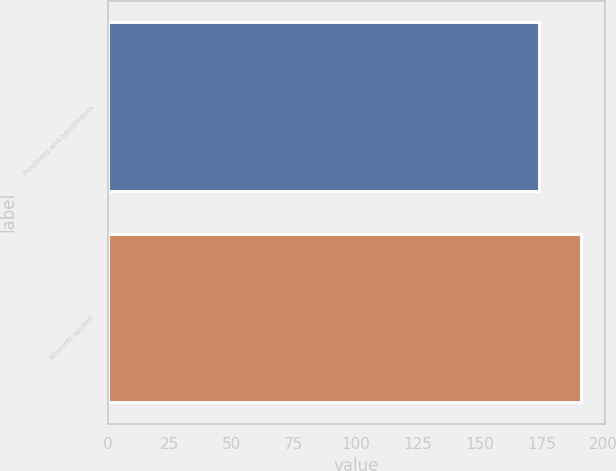Convert chart to OTSL. <chart><loc_0><loc_0><loc_500><loc_500><bar_chart><fcel>Provisions and adjustments<fcel>Amounts applied<nl><fcel>174<fcel>191<nl></chart> 